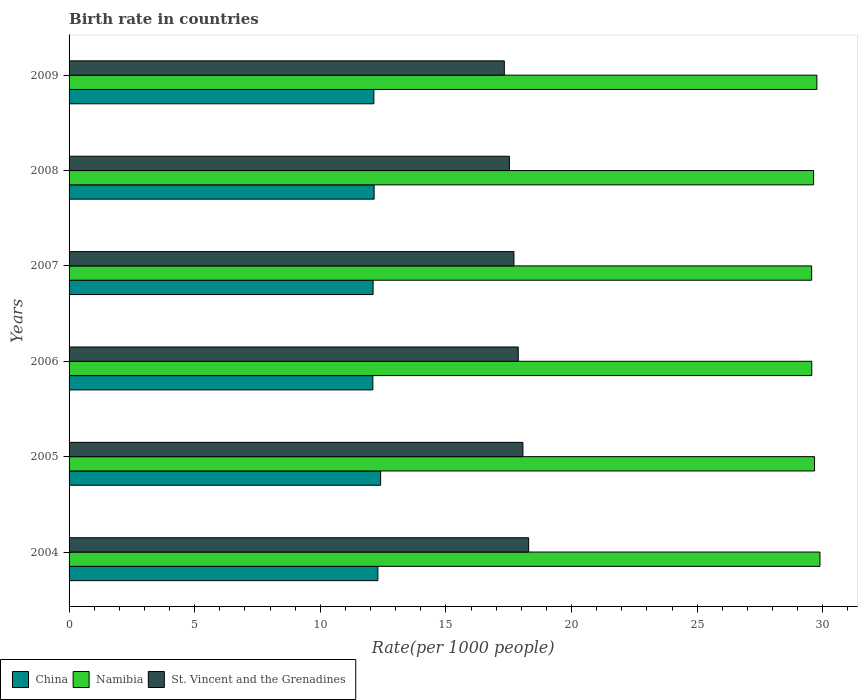How many different coloured bars are there?
Keep it short and to the point. 3. How many groups of bars are there?
Your answer should be compact. 6. Are the number of bars on each tick of the Y-axis equal?
Give a very brief answer. Yes. How many bars are there on the 5th tick from the bottom?
Keep it short and to the point. 3. What is the birth rate in Namibia in 2005?
Ensure brevity in your answer.  29.67. Across all years, what is the maximum birth rate in St. Vincent and the Grenadines?
Offer a very short reply. 18.29. Across all years, what is the minimum birth rate in St. Vincent and the Grenadines?
Give a very brief answer. 17.32. What is the total birth rate in St. Vincent and the Grenadines in the graph?
Your answer should be compact. 106.78. What is the difference between the birth rate in China in 2005 and that in 2007?
Make the answer very short. 0.3. What is the difference between the birth rate in Namibia in 2009 and the birth rate in St. Vincent and the Grenadines in 2008?
Make the answer very short. 12.24. What is the average birth rate in Namibia per year?
Provide a short and direct response. 29.68. In the year 2005, what is the difference between the birth rate in St. Vincent and the Grenadines and birth rate in China?
Ensure brevity in your answer.  5.66. What is the ratio of the birth rate in China in 2005 to that in 2007?
Provide a succinct answer. 1.02. What is the difference between the highest and the second highest birth rate in Namibia?
Make the answer very short. 0.12. What is the difference between the highest and the lowest birth rate in St. Vincent and the Grenadines?
Your answer should be very brief. 0.97. In how many years, is the birth rate in Namibia greater than the average birth rate in Namibia taken over all years?
Your answer should be compact. 2. Is the sum of the birth rate in China in 2006 and 2009 greater than the maximum birth rate in Namibia across all years?
Ensure brevity in your answer.  No. What does the 2nd bar from the bottom in 2005 represents?
Give a very brief answer. Namibia. Is it the case that in every year, the sum of the birth rate in St. Vincent and the Grenadines and birth rate in Namibia is greater than the birth rate in China?
Your answer should be very brief. Yes. How many bars are there?
Your answer should be very brief. 18. Are all the bars in the graph horizontal?
Offer a very short reply. Yes. How many years are there in the graph?
Your response must be concise. 6. Are the values on the major ticks of X-axis written in scientific E-notation?
Your answer should be compact. No. How are the legend labels stacked?
Give a very brief answer. Horizontal. What is the title of the graph?
Provide a short and direct response. Birth rate in countries. Does "Brunei Darussalam" appear as one of the legend labels in the graph?
Give a very brief answer. No. What is the label or title of the X-axis?
Offer a terse response. Rate(per 1000 people). What is the Rate(per 1000 people) of China in 2004?
Your response must be concise. 12.29. What is the Rate(per 1000 people) in Namibia in 2004?
Give a very brief answer. 29.88. What is the Rate(per 1000 people) of St. Vincent and the Grenadines in 2004?
Offer a very short reply. 18.29. What is the Rate(per 1000 people) of China in 2005?
Offer a very short reply. 12.4. What is the Rate(per 1000 people) in Namibia in 2005?
Your answer should be compact. 29.67. What is the Rate(per 1000 people) in St. Vincent and the Grenadines in 2005?
Offer a very short reply. 18.06. What is the Rate(per 1000 people) in China in 2006?
Provide a short and direct response. 12.09. What is the Rate(per 1000 people) of Namibia in 2006?
Provide a short and direct response. 29.56. What is the Rate(per 1000 people) of St. Vincent and the Grenadines in 2006?
Provide a succinct answer. 17.88. What is the Rate(per 1000 people) of China in 2007?
Ensure brevity in your answer.  12.1. What is the Rate(per 1000 people) in Namibia in 2007?
Offer a very short reply. 29.55. What is the Rate(per 1000 people) of St. Vincent and the Grenadines in 2007?
Give a very brief answer. 17.71. What is the Rate(per 1000 people) in China in 2008?
Your response must be concise. 12.14. What is the Rate(per 1000 people) of Namibia in 2008?
Ensure brevity in your answer.  29.63. What is the Rate(per 1000 people) of St. Vincent and the Grenadines in 2008?
Give a very brief answer. 17.52. What is the Rate(per 1000 people) of China in 2009?
Ensure brevity in your answer.  12.13. What is the Rate(per 1000 people) of Namibia in 2009?
Offer a terse response. 29.76. What is the Rate(per 1000 people) of St. Vincent and the Grenadines in 2009?
Your answer should be very brief. 17.32. Across all years, what is the maximum Rate(per 1000 people) of China?
Provide a short and direct response. 12.4. Across all years, what is the maximum Rate(per 1000 people) of Namibia?
Your answer should be compact. 29.88. Across all years, what is the maximum Rate(per 1000 people) of St. Vincent and the Grenadines?
Your response must be concise. 18.29. Across all years, what is the minimum Rate(per 1000 people) of China?
Offer a very short reply. 12.09. Across all years, what is the minimum Rate(per 1000 people) of Namibia?
Offer a terse response. 29.55. Across all years, what is the minimum Rate(per 1000 people) in St. Vincent and the Grenadines?
Provide a short and direct response. 17.32. What is the total Rate(per 1000 people) in China in the graph?
Provide a short and direct response. 73.15. What is the total Rate(per 1000 people) in Namibia in the graph?
Ensure brevity in your answer.  178.06. What is the total Rate(per 1000 people) of St. Vincent and the Grenadines in the graph?
Keep it short and to the point. 106.78. What is the difference between the Rate(per 1000 people) in China in 2004 and that in 2005?
Your answer should be very brief. -0.11. What is the difference between the Rate(per 1000 people) in Namibia in 2004 and that in 2005?
Your answer should be very brief. 0.22. What is the difference between the Rate(per 1000 people) in St. Vincent and the Grenadines in 2004 and that in 2005?
Ensure brevity in your answer.  0.23. What is the difference between the Rate(per 1000 people) in Namibia in 2004 and that in 2006?
Your answer should be compact. 0.33. What is the difference between the Rate(per 1000 people) in St. Vincent and the Grenadines in 2004 and that in 2006?
Give a very brief answer. 0.41. What is the difference between the Rate(per 1000 people) of China in 2004 and that in 2007?
Provide a short and direct response. 0.19. What is the difference between the Rate(per 1000 people) of Namibia in 2004 and that in 2007?
Your response must be concise. 0.33. What is the difference between the Rate(per 1000 people) in St. Vincent and the Grenadines in 2004 and that in 2007?
Give a very brief answer. 0.58. What is the difference between the Rate(per 1000 people) in China in 2004 and that in 2008?
Ensure brevity in your answer.  0.15. What is the difference between the Rate(per 1000 people) in Namibia in 2004 and that in 2008?
Offer a terse response. 0.25. What is the difference between the Rate(per 1000 people) of St. Vincent and the Grenadines in 2004 and that in 2008?
Give a very brief answer. 0.77. What is the difference between the Rate(per 1000 people) of China in 2004 and that in 2009?
Your answer should be very brief. 0.16. What is the difference between the Rate(per 1000 people) in Namibia in 2004 and that in 2009?
Your answer should be compact. 0.12. What is the difference between the Rate(per 1000 people) in St. Vincent and the Grenadines in 2004 and that in 2009?
Ensure brevity in your answer.  0.97. What is the difference between the Rate(per 1000 people) in China in 2005 and that in 2006?
Provide a succinct answer. 0.31. What is the difference between the Rate(per 1000 people) in Namibia in 2005 and that in 2006?
Provide a short and direct response. 0.11. What is the difference between the Rate(per 1000 people) of St. Vincent and the Grenadines in 2005 and that in 2006?
Give a very brief answer. 0.18. What is the difference between the Rate(per 1000 people) of China in 2005 and that in 2007?
Your response must be concise. 0.3. What is the difference between the Rate(per 1000 people) in Namibia in 2005 and that in 2007?
Provide a succinct answer. 0.11. What is the difference between the Rate(per 1000 people) of St. Vincent and the Grenadines in 2005 and that in 2007?
Offer a very short reply. 0.36. What is the difference between the Rate(per 1000 people) of China in 2005 and that in 2008?
Ensure brevity in your answer.  0.26. What is the difference between the Rate(per 1000 people) in Namibia in 2005 and that in 2008?
Give a very brief answer. 0.04. What is the difference between the Rate(per 1000 people) of St. Vincent and the Grenadines in 2005 and that in 2008?
Your answer should be compact. 0.54. What is the difference between the Rate(per 1000 people) in China in 2005 and that in 2009?
Offer a terse response. 0.27. What is the difference between the Rate(per 1000 people) of Namibia in 2005 and that in 2009?
Ensure brevity in your answer.  -0.1. What is the difference between the Rate(per 1000 people) in St. Vincent and the Grenadines in 2005 and that in 2009?
Provide a succinct answer. 0.74. What is the difference between the Rate(per 1000 people) in China in 2006 and that in 2007?
Keep it short and to the point. -0.01. What is the difference between the Rate(per 1000 people) in Namibia in 2006 and that in 2007?
Give a very brief answer. 0.01. What is the difference between the Rate(per 1000 people) in St. Vincent and the Grenadines in 2006 and that in 2007?
Your answer should be compact. 0.17. What is the difference between the Rate(per 1000 people) in Namibia in 2006 and that in 2008?
Offer a terse response. -0.07. What is the difference between the Rate(per 1000 people) of St. Vincent and the Grenadines in 2006 and that in 2008?
Your answer should be very brief. 0.35. What is the difference between the Rate(per 1000 people) in China in 2006 and that in 2009?
Offer a very short reply. -0.04. What is the difference between the Rate(per 1000 people) in Namibia in 2006 and that in 2009?
Provide a short and direct response. -0.2. What is the difference between the Rate(per 1000 people) in St. Vincent and the Grenadines in 2006 and that in 2009?
Provide a succinct answer. 0.55. What is the difference between the Rate(per 1000 people) in China in 2007 and that in 2008?
Keep it short and to the point. -0.04. What is the difference between the Rate(per 1000 people) in Namibia in 2007 and that in 2008?
Provide a succinct answer. -0.08. What is the difference between the Rate(per 1000 people) in St. Vincent and the Grenadines in 2007 and that in 2008?
Your response must be concise. 0.18. What is the difference between the Rate(per 1000 people) of China in 2007 and that in 2009?
Make the answer very short. -0.03. What is the difference between the Rate(per 1000 people) of Namibia in 2007 and that in 2009?
Make the answer very short. -0.21. What is the difference between the Rate(per 1000 people) in St. Vincent and the Grenadines in 2007 and that in 2009?
Offer a very short reply. 0.38. What is the difference between the Rate(per 1000 people) in China in 2008 and that in 2009?
Your answer should be compact. 0.01. What is the difference between the Rate(per 1000 people) in Namibia in 2008 and that in 2009?
Your answer should be very brief. -0.13. What is the difference between the Rate(per 1000 people) in St. Vincent and the Grenadines in 2008 and that in 2009?
Provide a short and direct response. 0.2. What is the difference between the Rate(per 1000 people) in China in 2004 and the Rate(per 1000 people) in Namibia in 2005?
Make the answer very short. -17.38. What is the difference between the Rate(per 1000 people) in China in 2004 and the Rate(per 1000 people) in St. Vincent and the Grenadines in 2005?
Provide a succinct answer. -5.77. What is the difference between the Rate(per 1000 people) of Namibia in 2004 and the Rate(per 1000 people) of St. Vincent and the Grenadines in 2005?
Provide a short and direct response. 11.82. What is the difference between the Rate(per 1000 people) in China in 2004 and the Rate(per 1000 people) in Namibia in 2006?
Offer a terse response. -17.27. What is the difference between the Rate(per 1000 people) of China in 2004 and the Rate(per 1000 people) of St. Vincent and the Grenadines in 2006?
Your answer should be compact. -5.59. What is the difference between the Rate(per 1000 people) of Namibia in 2004 and the Rate(per 1000 people) of St. Vincent and the Grenadines in 2006?
Offer a terse response. 12.01. What is the difference between the Rate(per 1000 people) of China in 2004 and the Rate(per 1000 people) of Namibia in 2007?
Provide a succinct answer. -17.26. What is the difference between the Rate(per 1000 people) of China in 2004 and the Rate(per 1000 people) of St. Vincent and the Grenadines in 2007?
Keep it short and to the point. -5.42. What is the difference between the Rate(per 1000 people) in Namibia in 2004 and the Rate(per 1000 people) in St. Vincent and the Grenadines in 2007?
Make the answer very short. 12.18. What is the difference between the Rate(per 1000 people) in China in 2004 and the Rate(per 1000 people) in Namibia in 2008?
Give a very brief answer. -17.34. What is the difference between the Rate(per 1000 people) of China in 2004 and the Rate(per 1000 people) of St. Vincent and the Grenadines in 2008?
Offer a very short reply. -5.24. What is the difference between the Rate(per 1000 people) in Namibia in 2004 and the Rate(per 1000 people) in St. Vincent and the Grenadines in 2008?
Provide a succinct answer. 12.36. What is the difference between the Rate(per 1000 people) in China in 2004 and the Rate(per 1000 people) in Namibia in 2009?
Keep it short and to the point. -17.47. What is the difference between the Rate(per 1000 people) of China in 2004 and the Rate(per 1000 people) of St. Vincent and the Grenadines in 2009?
Your response must be concise. -5.03. What is the difference between the Rate(per 1000 people) in Namibia in 2004 and the Rate(per 1000 people) in St. Vincent and the Grenadines in 2009?
Offer a terse response. 12.56. What is the difference between the Rate(per 1000 people) of China in 2005 and the Rate(per 1000 people) of Namibia in 2006?
Your response must be concise. -17.16. What is the difference between the Rate(per 1000 people) of China in 2005 and the Rate(per 1000 people) of St. Vincent and the Grenadines in 2006?
Your answer should be compact. -5.48. What is the difference between the Rate(per 1000 people) of Namibia in 2005 and the Rate(per 1000 people) of St. Vincent and the Grenadines in 2006?
Provide a succinct answer. 11.79. What is the difference between the Rate(per 1000 people) of China in 2005 and the Rate(per 1000 people) of Namibia in 2007?
Provide a succinct answer. -17.15. What is the difference between the Rate(per 1000 people) of China in 2005 and the Rate(per 1000 people) of St. Vincent and the Grenadines in 2007?
Provide a short and direct response. -5.31. What is the difference between the Rate(per 1000 people) in Namibia in 2005 and the Rate(per 1000 people) in St. Vincent and the Grenadines in 2007?
Your answer should be compact. 11.96. What is the difference between the Rate(per 1000 people) in China in 2005 and the Rate(per 1000 people) in Namibia in 2008?
Ensure brevity in your answer.  -17.23. What is the difference between the Rate(per 1000 people) in China in 2005 and the Rate(per 1000 people) in St. Vincent and the Grenadines in 2008?
Offer a terse response. -5.12. What is the difference between the Rate(per 1000 people) of Namibia in 2005 and the Rate(per 1000 people) of St. Vincent and the Grenadines in 2008?
Make the answer very short. 12.14. What is the difference between the Rate(per 1000 people) of China in 2005 and the Rate(per 1000 people) of Namibia in 2009?
Ensure brevity in your answer.  -17.36. What is the difference between the Rate(per 1000 people) of China in 2005 and the Rate(per 1000 people) of St. Vincent and the Grenadines in 2009?
Your answer should be very brief. -4.92. What is the difference between the Rate(per 1000 people) of Namibia in 2005 and the Rate(per 1000 people) of St. Vincent and the Grenadines in 2009?
Offer a very short reply. 12.34. What is the difference between the Rate(per 1000 people) in China in 2006 and the Rate(per 1000 people) in Namibia in 2007?
Your response must be concise. -17.46. What is the difference between the Rate(per 1000 people) in China in 2006 and the Rate(per 1000 people) in St. Vincent and the Grenadines in 2007?
Your response must be concise. -5.62. What is the difference between the Rate(per 1000 people) of Namibia in 2006 and the Rate(per 1000 people) of St. Vincent and the Grenadines in 2007?
Offer a very short reply. 11.85. What is the difference between the Rate(per 1000 people) of China in 2006 and the Rate(per 1000 people) of Namibia in 2008?
Offer a very short reply. -17.54. What is the difference between the Rate(per 1000 people) in China in 2006 and the Rate(per 1000 people) in St. Vincent and the Grenadines in 2008?
Your response must be concise. -5.43. What is the difference between the Rate(per 1000 people) in Namibia in 2006 and the Rate(per 1000 people) in St. Vincent and the Grenadines in 2008?
Provide a succinct answer. 12.03. What is the difference between the Rate(per 1000 people) of China in 2006 and the Rate(per 1000 people) of Namibia in 2009?
Give a very brief answer. -17.67. What is the difference between the Rate(per 1000 people) of China in 2006 and the Rate(per 1000 people) of St. Vincent and the Grenadines in 2009?
Your answer should be very brief. -5.23. What is the difference between the Rate(per 1000 people) in Namibia in 2006 and the Rate(per 1000 people) in St. Vincent and the Grenadines in 2009?
Your answer should be very brief. 12.24. What is the difference between the Rate(per 1000 people) in China in 2007 and the Rate(per 1000 people) in Namibia in 2008?
Make the answer very short. -17.53. What is the difference between the Rate(per 1000 people) of China in 2007 and the Rate(per 1000 people) of St. Vincent and the Grenadines in 2008?
Ensure brevity in your answer.  -5.42. What is the difference between the Rate(per 1000 people) of Namibia in 2007 and the Rate(per 1000 people) of St. Vincent and the Grenadines in 2008?
Provide a succinct answer. 12.03. What is the difference between the Rate(per 1000 people) of China in 2007 and the Rate(per 1000 people) of Namibia in 2009?
Give a very brief answer. -17.66. What is the difference between the Rate(per 1000 people) in China in 2007 and the Rate(per 1000 people) in St. Vincent and the Grenadines in 2009?
Your answer should be compact. -5.22. What is the difference between the Rate(per 1000 people) in Namibia in 2007 and the Rate(per 1000 people) in St. Vincent and the Grenadines in 2009?
Give a very brief answer. 12.23. What is the difference between the Rate(per 1000 people) in China in 2008 and the Rate(per 1000 people) in Namibia in 2009?
Ensure brevity in your answer.  -17.62. What is the difference between the Rate(per 1000 people) of China in 2008 and the Rate(per 1000 people) of St. Vincent and the Grenadines in 2009?
Your response must be concise. -5.18. What is the difference between the Rate(per 1000 people) in Namibia in 2008 and the Rate(per 1000 people) in St. Vincent and the Grenadines in 2009?
Your answer should be compact. 12.31. What is the average Rate(per 1000 people) of China per year?
Keep it short and to the point. 12.19. What is the average Rate(per 1000 people) in Namibia per year?
Keep it short and to the point. 29.68. What is the average Rate(per 1000 people) in St. Vincent and the Grenadines per year?
Provide a succinct answer. 17.8. In the year 2004, what is the difference between the Rate(per 1000 people) in China and Rate(per 1000 people) in Namibia?
Your response must be concise. -17.59. In the year 2004, what is the difference between the Rate(per 1000 people) in China and Rate(per 1000 people) in St. Vincent and the Grenadines?
Make the answer very short. -6. In the year 2004, what is the difference between the Rate(per 1000 people) of Namibia and Rate(per 1000 people) of St. Vincent and the Grenadines?
Your response must be concise. 11.59. In the year 2005, what is the difference between the Rate(per 1000 people) of China and Rate(per 1000 people) of Namibia?
Offer a terse response. -17.27. In the year 2005, what is the difference between the Rate(per 1000 people) in China and Rate(per 1000 people) in St. Vincent and the Grenadines?
Give a very brief answer. -5.66. In the year 2005, what is the difference between the Rate(per 1000 people) of Namibia and Rate(per 1000 people) of St. Vincent and the Grenadines?
Offer a terse response. 11.61. In the year 2006, what is the difference between the Rate(per 1000 people) of China and Rate(per 1000 people) of Namibia?
Your answer should be very brief. -17.47. In the year 2006, what is the difference between the Rate(per 1000 people) in China and Rate(per 1000 people) in St. Vincent and the Grenadines?
Ensure brevity in your answer.  -5.79. In the year 2006, what is the difference between the Rate(per 1000 people) of Namibia and Rate(per 1000 people) of St. Vincent and the Grenadines?
Your answer should be compact. 11.68. In the year 2007, what is the difference between the Rate(per 1000 people) of China and Rate(per 1000 people) of Namibia?
Provide a short and direct response. -17.45. In the year 2007, what is the difference between the Rate(per 1000 people) of China and Rate(per 1000 people) of St. Vincent and the Grenadines?
Provide a succinct answer. -5.61. In the year 2007, what is the difference between the Rate(per 1000 people) of Namibia and Rate(per 1000 people) of St. Vincent and the Grenadines?
Ensure brevity in your answer.  11.85. In the year 2008, what is the difference between the Rate(per 1000 people) in China and Rate(per 1000 people) in Namibia?
Offer a very short reply. -17.49. In the year 2008, what is the difference between the Rate(per 1000 people) of China and Rate(per 1000 people) of St. Vincent and the Grenadines?
Offer a very short reply. -5.38. In the year 2008, what is the difference between the Rate(per 1000 people) of Namibia and Rate(per 1000 people) of St. Vincent and the Grenadines?
Make the answer very short. 12.11. In the year 2009, what is the difference between the Rate(per 1000 people) in China and Rate(per 1000 people) in Namibia?
Your answer should be very brief. -17.63. In the year 2009, what is the difference between the Rate(per 1000 people) in China and Rate(per 1000 people) in St. Vincent and the Grenadines?
Provide a succinct answer. -5.19. In the year 2009, what is the difference between the Rate(per 1000 people) in Namibia and Rate(per 1000 people) in St. Vincent and the Grenadines?
Your response must be concise. 12.44. What is the ratio of the Rate(per 1000 people) in China in 2004 to that in 2005?
Offer a terse response. 0.99. What is the ratio of the Rate(per 1000 people) of Namibia in 2004 to that in 2005?
Your answer should be very brief. 1.01. What is the ratio of the Rate(per 1000 people) in St. Vincent and the Grenadines in 2004 to that in 2005?
Provide a short and direct response. 1.01. What is the ratio of the Rate(per 1000 people) in China in 2004 to that in 2006?
Your answer should be very brief. 1.02. What is the ratio of the Rate(per 1000 people) of Namibia in 2004 to that in 2006?
Give a very brief answer. 1.01. What is the ratio of the Rate(per 1000 people) of St. Vincent and the Grenadines in 2004 to that in 2006?
Your answer should be compact. 1.02. What is the ratio of the Rate(per 1000 people) of China in 2004 to that in 2007?
Ensure brevity in your answer.  1.02. What is the ratio of the Rate(per 1000 people) in Namibia in 2004 to that in 2007?
Give a very brief answer. 1.01. What is the ratio of the Rate(per 1000 people) in St. Vincent and the Grenadines in 2004 to that in 2007?
Offer a very short reply. 1.03. What is the ratio of the Rate(per 1000 people) in China in 2004 to that in 2008?
Provide a succinct answer. 1.01. What is the ratio of the Rate(per 1000 people) of Namibia in 2004 to that in 2008?
Give a very brief answer. 1.01. What is the ratio of the Rate(per 1000 people) of St. Vincent and the Grenadines in 2004 to that in 2008?
Provide a succinct answer. 1.04. What is the ratio of the Rate(per 1000 people) of China in 2004 to that in 2009?
Provide a short and direct response. 1.01. What is the ratio of the Rate(per 1000 people) in St. Vincent and the Grenadines in 2004 to that in 2009?
Ensure brevity in your answer.  1.06. What is the ratio of the Rate(per 1000 people) of China in 2005 to that in 2006?
Offer a terse response. 1.03. What is the ratio of the Rate(per 1000 people) in Namibia in 2005 to that in 2006?
Offer a terse response. 1. What is the ratio of the Rate(per 1000 people) of St. Vincent and the Grenadines in 2005 to that in 2006?
Offer a very short reply. 1.01. What is the ratio of the Rate(per 1000 people) of China in 2005 to that in 2007?
Your answer should be very brief. 1.02. What is the ratio of the Rate(per 1000 people) in Namibia in 2005 to that in 2007?
Offer a very short reply. 1. What is the ratio of the Rate(per 1000 people) of St. Vincent and the Grenadines in 2005 to that in 2007?
Make the answer very short. 1.02. What is the ratio of the Rate(per 1000 people) in China in 2005 to that in 2008?
Offer a terse response. 1.02. What is the ratio of the Rate(per 1000 people) of St. Vincent and the Grenadines in 2005 to that in 2008?
Provide a succinct answer. 1.03. What is the ratio of the Rate(per 1000 people) of China in 2005 to that in 2009?
Ensure brevity in your answer.  1.02. What is the ratio of the Rate(per 1000 people) in St. Vincent and the Grenadines in 2005 to that in 2009?
Provide a succinct answer. 1.04. What is the ratio of the Rate(per 1000 people) in St. Vincent and the Grenadines in 2006 to that in 2007?
Provide a succinct answer. 1.01. What is the ratio of the Rate(per 1000 people) in China in 2006 to that in 2008?
Offer a very short reply. 1. What is the ratio of the Rate(per 1000 people) in St. Vincent and the Grenadines in 2006 to that in 2008?
Give a very brief answer. 1.02. What is the ratio of the Rate(per 1000 people) in China in 2006 to that in 2009?
Provide a succinct answer. 1. What is the ratio of the Rate(per 1000 people) of Namibia in 2006 to that in 2009?
Keep it short and to the point. 0.99. What is the ratio of the Rate(per 1000 people) in St. Vincent and the Grenadines in 2006 to that in 2009?
Give a very brief answer. 1.03. What is the ratio of the Rate(per 1000 people) of China in 2007 to that in 2008?
Provide a succinct answer. 1. What is the ratio of the Rate(per 1000 people) in St. Vincent and the Grenadines in 2007 to that in 2008?
Make the answer very short. 1.01. What is the ratio of the Rate(per 1000 people) in China in 2007 to that in 2009?
Your response must be concise. 1. What is the ratio of the Rate(per 1000 people) in St. Vincent and the Grenadines in 2007 to that in 2009?
Provide a short and direct response. 1.02. What is the ratio of the Rate(per 1000 people) in St. Vincent and the Grenadines in 2008 to that in 2009?
Offer a terse response. 1.01. What is the difference between the highest and the second highest Rate(per 1000 people) of China?
Offer a very short reply. 0.11. What is the difference between the highest and the second highest Rate(per 1000 people) in Namibia?
Provide a succinct answer. 0.12. What is the difference between the highest and the second highest Rate(per 1000 people) of St. Vincent and the Grenadines?
Offer a terse response. 0.23. What is the difference between the highest and the lowest Rate(per 1000 people) of China?
Ensure brevity in your answer.  0.31. What is the difference between the highest and the lowest Rate(per 1000 people) in Namibia?
Provide a succinct answer. 0.33. What is the difference between the highest and the lowest Rate(per 1000 people) in St. Vincent and the Grenadines?
Give a very brief answer. 0.97. 